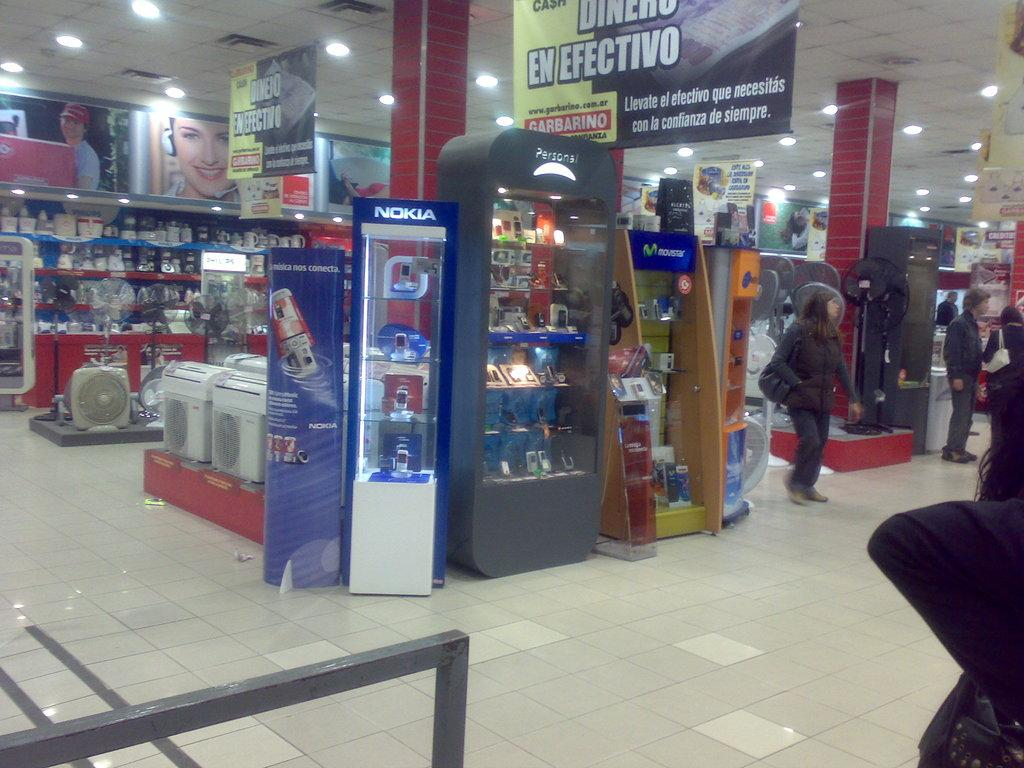<image>
Present a compact description of the photo's key features. the store has a nokia stand of items in it 